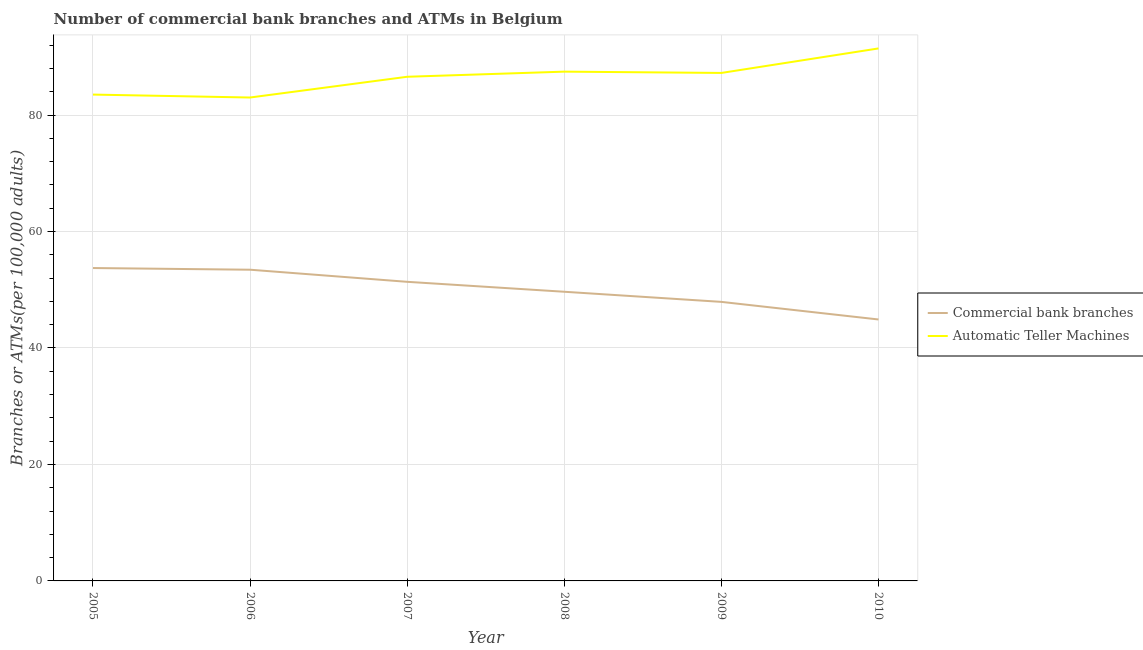Is the number of lines equal to the number of legend labels?
Make the answer very short. Yes. What is the number of commercal bank branches in 2008?
Make the answer very short. 49.65. Across all years, what is the maximum number of commercal bank branches?
Provide a short and direct response. 53.73. Across all years, what is the minimum number of atms?
Ensure brevity in your answer.  83.01. In which year was the number of atms maximum?
Your answer should be very brief. 2010. In which year was the number of commercal bank branches minimum?
Make the answer very short. 2010. What is the total number of atms in the graph?
Provide a short and direct response. 519.21. What is the difference between the number of atms in 2005 and that in 2009?
Provide a short and direct response. -3.71. What is the difference between the number of atms in 2009 and the number of commercal bank branches in 2008?
Keep it short and to the point. 37.57. What is the average number of atms per year?
Offer a terse response. 86.53. In the year 2010, what is the difference between the number of commercal bank branches and number of atms?
Provide a short and direct response. -46.54. In how many years, is the number of atms greater than 76?
Offer a very short reply. 6. What is the ratio of the number of atms in 2007 to that in 2009?
Offer a very short reply. 0.99. Is the number of commercal bank branches in 2008 less than that in 2009?
Give a very brief answer. No. What is the difference between the highest and the second highest number of atms?
Your answer should be very brief. 3.98. What is the difference between the highest and the lowest number of commercal bank branches?
Keep it short and to the point. 8.83. In how many years, is the number of atms greater than the average number of atms taken over all years?
Your answer should be compact. 4. Is the number of atms strictly greater than the number of commercal bank branches over the years?
Provide a succinct answer. Yes. Is the number of atms strictly less than the number of commercal bank branches over the years?
Your response must be concise. No. How many years are there in the graph?
Your response must be concise. 6. Are the values on the major ticks of Y-axis written in scientific E-notation?
Offer a very short reply. No. Does the graph contain any zero values?
Your answer should be compact. No. How are the legend labels stacked?
Your answer should be very brief. Vertical. What is the title of the graph?
Provide a short and direct response. Number of commercial bank branches and ATMs in Belgium. Does "Subsidies" appear as one of the legend labels in the graph?
Give a very brief answer. No. What is the label or title of the X-axis?
Offer a very short reply. Year. What is the label or title of the Y-axis?
Your response must be concise. Branches or ATMs(per 100,0 adults). What is the Branches or ATMs(per 100,000 adults) in Commercial bank branches in 2005?
Offer a very short reply. 53.73. What is the Branches or ATMs(per 100,000 adults) in Automatic Teller Machines in 2005?
Your answer should be compact. 83.51. What is the Branches or ATMs(per 100,000 adults) of Commercial bank branches in 2006?
Your answer should be very brief. 53.44. What is the Branches or ATMs(per 100,000 adults) of Automatic Teller Machines in 2006?
Give a very brief answer. 83.01. What is the Branches or ATMs(per 100,000 adults) in Commercial bank branches in 2007?
Provide a short and direct response. 51.36. What is the Branches or ATMs(per 100,000 adults) of Automatic Teller Machines in 2007?
Ensure brevity in your answer.  86.57. What is the Branches or ATMs(per 100,000 adults) of Commercial bank branches in 2008?
Ensure brevity in your answer.  49.65. What is the Branches or ATMs(per 100,000 adults) of Automatic Teller Machines in 2008?
Your answer should be very brief. 87.45. What is the Branches or ATMs(per 100,000 adults) of Commercial bank branches in 2009?
Offer a terse response. 47.92. What is the Branches or ATMs(per 100,000 adults) in Automatic Teller Machines in 2009?
Ensure brevity in your answer.  87.23. What is the Branches or ATMs(per 100,000 adults) in Commercial bank branches in 2010?
Your answer should be compact. 44.89. What is the Branches or ATMs(per 100,000 adults) of Automatic Teller Machines in 2010?
Provide a short and direct response. 91.44. Across all years, what is the maximum Branches or ATMs(per 100,000 adults) of Commercial bank branches?
Provide a succinct answer. 53.73. Across all years, what is the maximum Branches or ATMs(per 100,000 adults) in Automatic Teller Machines?
Keep it short and to the point. 91.44. Across all years, what is the minimum Branches or ATMs(per 100,000 adults) of Commercial bank branches?
Offer a terse response. 44.89. Across all years, what is the minimum Branches or ATMs(per 100,000 adults) in Automatic Teller Machines?
Provide a succinct answer. 83.01. What is the total Branches or ATMs(per 100,000 adults) of Commercial bank branches in the graph?
Provide a succinct answer. 300.99. What is the total Branches or ATMs(per 100,000 adults) of Automatic Teller Machines in the graph?
Provide a short and direct response. 519.21. What is the difference between the Branches or ATMs(per 100,000 adults) in Commercial bank branches in 2005 and that in 2006?
Offer a very short reply. 0.29. What is the difference between the Branches or ATMs(per 100,000 adults) of Automatic Teller Machines in 2005 and that in 2006?
Give a very brief answer. 0.5. What is the difference between the Branches or ATMs(per 100,000 adults) in Commercial bank branches in 2005 and that in 2007?
Offer a terse response. 2.37. What is the difference between the Branches or ATMs(per 100,000 adults) in Automatic Teller Machines in 2005 and that in 2007?
Your answer should be very brief. -3.06. What is the difference between the Branches or ATMs(per 100,000 adults) of Commercial bank branches in 2005 and that in 2008?
Provide a short and direct response. 4.07. What is the difference between the Branches or ATMs(per 100,000 adults) in Automatic Teller Machines in 2005 and that in 2008?
Make the answer very short. -3.94. What is the difference between the Branches or ATMs(per 100,000 adults) of Commercial bank branches in 2005 and that in 2009?
Provide a short and direct response. 5.81. What is the difference between the Branches or ATMs(per 100,000 adults) in Automatic Teller Machines in 2005 and that in 2009?
Your answer should be very brief. -3.71. What is the difference between the Branches or ATMs(per 100,000 adults) in Commercial bank branches in 2005 and that in 2010?
Give a very brief answer. 8.83. What is the difference between the Branches or ATMs(per 100,000 adults) of Automatic Teller Machines in 2005 and that in 2010?
Give a very brief answer. -7.92. What is the difference between the Branches or ATMs(per 100,000 adults) in Commercial bank branches in 2006 and that in 2007?
Make the answer very short. 2.08. What is the difference between the Branches or ATMs(per 100,000 adults) of Automatic Teller Machines in 2006 and that in 2007?
Offer a very short reply. -3.56. What is the difference between the Branches or ATMs(per 100,000 adults) in Commercial bank branches in 2006 and that in 2008?
Make the answer very short. 3.79. What is the difference between the Branches or ATMs(per 100,000 adults) of Automatic Teller Machines in 2006 and that in 2008?
Your answer should be compact. -4.44. What is the difference between the Branches or ATMs(per 100,000 adults) in Commercial bank branches in 2006 and that in 2009?
Your answer should be compact. 5.52. What is the difference between the Branches or ATMs(per 100,000 adults) of Automatic Teller Machines in 2006 and that in 2009?
Your answer should be compact. -4.22. What is the difference between the Branches or ATMs(per 100,000 adults) in Commercial bank branches in 2006 and that in 2010?
Offer a terse response. 8.55. What is the difference between the Branches or ATMs(per 100,000 adults) in Automatic Teller Machines in 2006 and that in 2010?
Provide a short and direct response. -8.43. What is the difference between the Branches or ATMs(per 100,000 adults) in Commercial bank branches in 2007 and that in 2008?
Give a very brief answer. 1.71. What is the difference between the Branches or ATMs(per 100,000 adults) in Automatic Teller Machines in 2007 and that in 2008?
Your response must be concise. -0.88. What is the difference between the Branches or ATMs(per 100,000 adults) in Commercial bank branches in 2007 and that in 2009?
Keep it short and to the point. 3.44. What is the difference between the Branches or ATMs(per 100,000 adults) of Automatic Teller Machines in 2007 and that in 2009?
Your response must be concise. -0.66. What is the difference between the Branches or ATMs(per 100,000 adults) of Commercial bank branches in 2007 and that in 2010?
Your answer should be very brief. 6.47. What is the difference between the Branches or ATMs(per 100,000 adults) in Automatic Teller Machines in 2007 and that in 2010?
Give a very brief answer. -4.87. What is the difference between the Branches or ATMs(per 100,000 adults) in Commercial bank branches in 2008 and that in 2009?
Offer a terse response. 1.74. What is the difference between the Branches or ATMs(per 100,000 adults) of Automatic Teller Machines in 2008 and that in 2009?
Offer a terse response. 0.22. What is the difference between the Branches or ATMs(per 100,000 adults) of Commercial bank branches in 2008 and that in 2010?
Your answer should be very brief. 4.76. What is the difference between the Branches or ATMs(per 100,000 adults) of Automatic Teller Machines in 2008 and that in 2010?
Your answer should be compact. -3.98. What is the difference between the Branches or ATMs(per 100,000 adults) in Commercial bank branches in 2009 and that in 2010?
Provide a short and direct response. 3.02. What is the difference between the Branches or ATMs(per 100,000 adults) of Automatic Teller Machines in 2009 and that in 2010?
Offer a terse response. -4.21. What is the difference between the Branches or ATMs(per 100,000 adults) in Commercial bank branches in 2005 and the Branches or ATMs(per 100,000 adults) in Automatic Teller Machines in 2006?
Ensure brevity in your answer.  -29.28. What is the difference between the Branches or ATMs(per 100,000 adults) of Commercial bank branches in 2005 and the Branches or ATMs(per 100,000 adults) of Automatic Teller Machines in 2007?
Ensure brevity in your answer.  -32.84. What is the difference between the Branches or ATMs(per 100,000 adults) in Commercial bank branches in 2005 and the Branches or ATMs(per 100,000 adults) in Automatic Teller Machines in 2008?
Offer a terse response. -33.73. What is the difference between the Branches or ATMs(per 100,000 adults) of Commercial bank branches in 2005 and the Branches or ATMs(per 100,000 adults) of Automatic Teller Machines in 2009?
Offer a very short reply. -33.5. What is the difference between the Branches or ATMs(per 100,000 adults) of Commercial bank branches in 2005 and the Branches or ATMs(per 100,000 adults) of Automatic Teller Machines in 2010?
Your response must be concise. -37.71. What is the difference between the Branches or ATMs(per 100,000 adults) in Commercial bank branches in 2006 and the Branches or ATMs(per 100,000 adults) in Automatic Teller Machines in 2007?
Provide a short and direct response. -33.13. What is the difference between the Branches or ATMs(per 100,000 adults) in Commercial bank branches in 2006 and the Branches or ATMs(per 100,000 adults) in Automatic Teller Machines in 2008?
Ensure brevity in your answer.  -34.01. What is the difference between the Branches or ATMs(per 100,000 adults) of Commercial bank branches in 2006 and the Branches or ATMs(per 100,000 adults) of Automatic Teller Machines in 2009?
Your answer should be very brief. -33.79. What is the difference between the Branches or ATMs(per 100,000 adults) of Commercial bank branches in 2006 and the Branches or ATMs(per 100,000 adults) of Automatic Teller Machines in 2010?
Ensure brevity in your answer.  -38. What is the difference between the Branches or ATMs(per 100,000 adults) in Commercial bank branches in 2007 and the Branches or ATMs(per 100,000 adults) in Automatic Teller Machines in 2008?
Your response must be concise. -36.09. What is the difference between the Branches or ATMs(per 100,000 adults) in Commercial bank branches in 2007 and the Branches or ATMs(per 100,000 adults) in Automatic Teller Machines in 2009?
Your response must be concise. -35.87. What is the difference between the Branches or ATMs(per 100,000 adults) in Commercial bank branches in 2007 and the Branches or ATMs(per 100,000 adults) in Automatic Teller Machines in 2010?
Provide a succinct answer. -40.08. What is the difference between the Branches or ATMs(per 100,000 adults) of Commercial bank branches in 2008 and the Branches or ATMs(per 100,000 adults) of Automatic Teller Machines in 2009?
Make the answer very short. -37.57. What is the difference between the Branches or ATMs(per 100,000 adults) of Commercial bank branches in 2008 and the Branches or ATMs(per 100,000 adults) of Automatic Teller Machines in 2010?
Offer a very short reply. -41.78. What is the difference between the Branches or ATMs(per 100,000 adults) in Commercial bank branches in 2009 and the Branches or ATMs(per 100,000 adults) in Automatic Teller Machines in 2010?
Ensure brevity in your answer.  -43.52. What is the average Branches or ATMs(per 100,000 adults) in Commercial bank branches per year?
Offer a very short reply. 50.16. What is the average Branches or ATMs(per 100,000 adults) of Automatic Teller Machines per year?
Provide a succinct answer. 86.53. In the year 2005, what is the difference between the Branches or ATMs(per 100,000 adults) of Commercial bank branches and Branches or ATMs(per 100,000 adults) of Automatic Teller Machines?
Your answer should be compact. -29.79. In the year 2006, what is the difference between the Branches or ATMs(per 100,000 adults) of Commercial bank branches and Branches or ATMs(per 100,000 adults) of Automatic Teller Machines?
Offer a very short reply. -29.57. In the year 2007, what is the difference between the Branches or ATMs(per 100,000 adults) of Commercial bank branches and Branches or ATMs(per 100,000 adults) of Automatic Teller Machines?
Provide a short and direct response. -35.21. In the year 2008, what is the difference between the Branches or ATMs(per 100,000 adults) of Commercial bank branches and Branches or ATMs(per 100,000 adults) of Automatic Teller Machines?
Ensure brevity in your answer.  -37.8. In the year 2009, what is the difference between the Branches or ATMs(per 100,000 adults) of Commercial bank branches and Branches or ATMs(per 100,000 adults) of Automatic Teller Machines?
Your response must be concise. -39.31. In the year 2010, what is the difference between the Branches or ATMs(per 100,000 adults) in Commercial bank branches and Branches or ATMs(per 100,000 adults) in Automatic Teller Machines?
Your answer should be compact. -46.54. What is the ratio of the Branches or ATMs(per 100,000 adults) in Commercial bank branches in 2005 to that in 2006?
Your response must be concise. 1.01. What is the ratio of the Branches or ATMs(per 100,000 adults) in Commercial bank branches in 2005 to that in 2007?
Give a very brief answer. 1.05. What is the ratio of the Branches or ATMs(per 100,000 adults) in Automatic Teller Machines in 2005 to that in 2007?
Your answer should be compact. 0.96. What is the ratio of the Branches or ATMs(per 100,000 adults) of Commercial bank branches in 2005 to that in 2008?
Your answer should be compact. 1.08. What is the ratio of the Branches or ATMs(per 100,000 adults) of Automatic Teller Machines in 2005 to that in 2008?
Offer a very short reply. 0.95. What is the ratio of the Branches or ATMs(per 100,000 adults) in Commercial bank branches in 2005 to that in 2009?
Offer a very short reply. 1.12. What is the ratio of the Branches or ATMs(per 100,000 adults) in Automatic Teller Machines in 2005 to that in 2009?
Your response must be concise. 0.96. What is the ratio of the Branches or ATMs(per 100,000 adults) in Commercial bank branches in 2005 to that in 2010?
Your answer should be very brief. 1.2. What is the ratio of the Branches or ATMs(per 100,000 adults) in Automatic Teller Machines in 2005 to that in 2010?
Make the answer very short. 0.91. What is the ratio of the Branches or ATMs(per 100,000 adults) in Commercial bank branches in 2006 to that in 2007?
Offer a terse response. 1.04. What is the ratio of the Branches or ATMs(per 100,000 adults) of Automatic Teller Machines in 2006 to that in 2007?
Give a very brief answer. 0.96. What is the ratio of the Branches or ATMs(per 100,000 adults) of Commercial bank branches in 2006 to that in 2008?
Give a very brief answer. 1.08. What is the ratio of the Branches or ATMs(per 100,000 adults) in Automatic Teller Machines in 2006 to that in 2008?
Give a very brief answer. 0.95. What is the ratio of the Branches or ATMs(per 100,000 adults) of Commercial bank branches in 2006 to that in 2009?
Keep it short and to the point. 1.12. What is the ratio of the Branches or ATMs(per 100,000 adults) of Automatic Teller Machines in 2006 to that in 2009?
Your answer should be compact. 0.95. What is the ratio of the Branches or ATMs(per 100,000 adults) in Commercial bank branches in 2006 to that in 2010?
Your response must be concise. 1.19. What is the ratio of the Branches or ATMs(per 100,000 adults) in Automatic Teller Machines in 2006 to that in 2010?
Offer a terse response. 0.91. What is the ratio of the Branches or ATMs(per 100,000 adults) of Commercial bank branches in 2007 to that in 2008?
Give a very brief answer. 1.03. What is the ratio of the Branches or ATMs(per 100,000 adults) of Automatic Teller Machines in 2007 to that in 2008?
Provide a short and direct response. 0.99. What is the ratio of the Branches or ATMs(per 100,000 adults) in Commercial bank branches in 2007 to that in 2009?
Keep it short and to the point. 1.07. What is the ratio of the Branches or ATMs(per 100,000 adults) in Commercial bank branches in 2007 to that in 2010?
Ensure brevity in your answer.  1.14. What is the ratio of the Branches or ATMs(per 100,000 adults) in Automatic Teller Machines in 2007 to that in 2010?
Keep it short and to the point. 0.95. What is the ratio of the Branches or ATMs(per 100,000 adults) in Commercial bank branches in 2008 to that in 2009?
Your answer should be very brief. 1.04. What is the ratio of the Branches or ATMs(per 100,000 adults) in Commercial bank branches in 2008 to that in 2010?
Provide a succinct answer. 1.11. What is the ratio of the Branches or ATMs(per 100,000 adults) of Automatic Teller Machines in 2008 to that in 2010?
Your answer should be very brief. 0.96. What is the ratio of the Branches or ATMs(per 100,000 adults) in Commercial bank branches in 2009 to that in 2010?
Provide a succinct answer. 1.07. What is the ratio of the Branches or ATMs(per 100,000 adults) in Automatic Teller Machines in 2009 to that in 2010?
Provide a short and direct response. 0.95. What is the difference between the highest and the second highest Branches or ATMs(per 100,000 adults) of Commercial bank branches?
Offer a very short reply. 0.29. What is the difference between the highest and the second highest Branches or ATMs(per 100,000 adults) of Automatic Teller Machines?
Give a very brief answer. 3.98. What is the difference between the highest and the lowest Branches or ATMs(per 100,000 adults) in Commercial bank branches?
Your answer should be very brief. 8.83. What is the difference between the highest and the lowest Branches or ATMs(per 100,000 adults) in Automatic Teller Machines?
Provide a short and direct response. 8.43. 